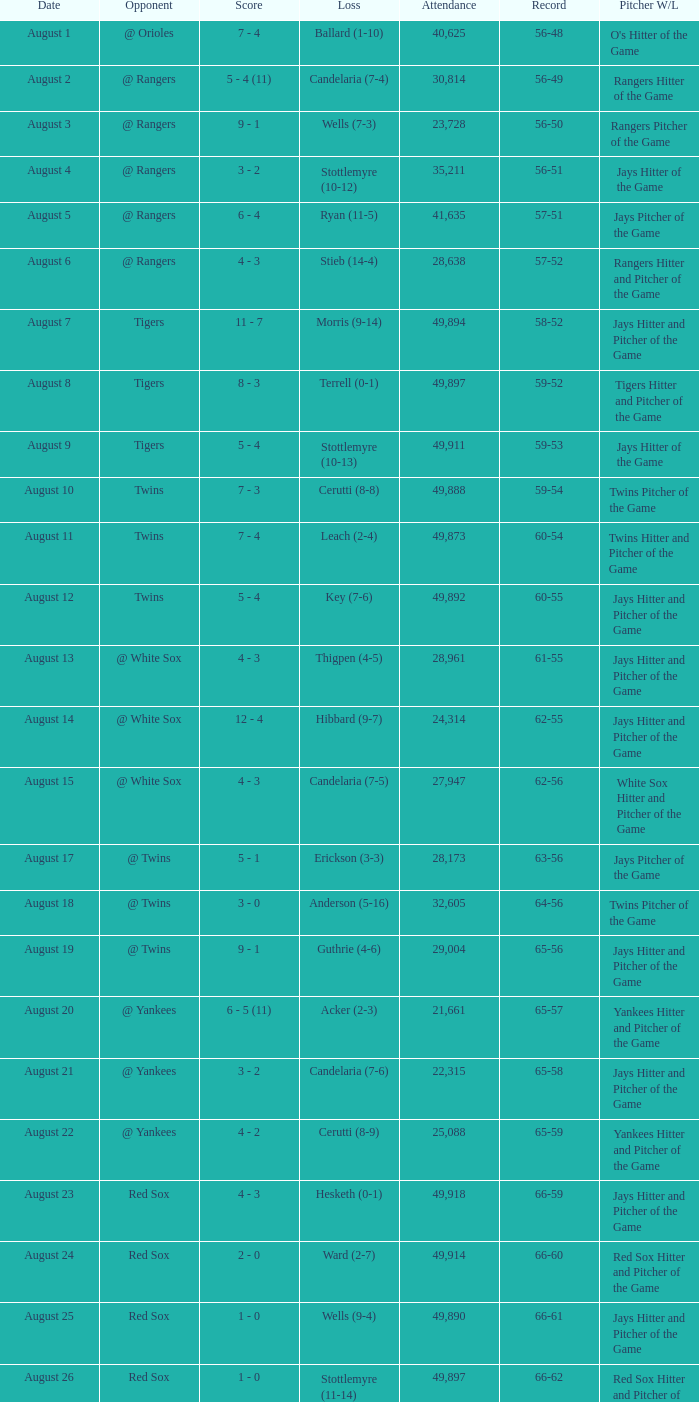Help me parse the entirety of this table. {'header': ['Date', 'Opponent', 'Score', 'Loss', 'Attendance', 'Record', 'Pitcher W/L'], 'rows': [['August 1', '@ Orioles', '7 - 4', 'Ballard (1-10)', '40,625', '56-48', "O's Hitter of the Game"], ['August 2', '@ Rangers', '5 - 4 (11)', 'Candelaria (7-4)', '30,814', '56-49', 'Rangers Hitter of the Game'], ['August 3', '@ Rangers', '9 - 1', 'Wells (7-3)', '23,728', '56-50', 'Rangers Pitcher of the Game'], ['August 4', '@ Rangers', '3 - 2', 'Stottlemyre (10-12)', '35,211', '56-51', 'Jays Hitter of the Game'], ['August 5', '@ Rangers', '6 - 4', 'Ryan (11-5)', '41,635', '57-51', 'Jays Pitcher of the Game'], ['August 6', '@ Rangers', '4 - 3', 'Stieb (14-4)', '28,638', '57-52', 'Rangers Hitter and Pitcher of the Game'], ['August 7', 'Tigers', '11 - 7', 'Morris (9-14)', '49,894', '58-52', 'Jays Hitter and Pitcher of the Game'], ['August 8', 'Tigers', '8 - 3', 'Terrell (0-1)', '49,897', '59-52', 'Tigers Hitter and Pitcher of the Game'], ['August 9', 'Tigers', '5 - 4', 'Stottlemyre (10-13)', '49,911', '59-53', 'Jays Hitter of the Game'], ['August 10', 'Twins', '7 - 3', 'Cerutti (8-8)', '49,888', '59-54', 'Twins Pitcher of the Game'], ['August 11', 'Twins', '7 - 4', 'Leach (2-4)', '49,873', '60-54', 'Twins Hitter and Pitcher of the Game'], ['August 12', 'Twins', '5 - 4', 'Key (7-6)', '49,892', '60-55', 'Jays Hitter and Pitcher of the Game'], ['August 13', '@ White Sox', '4 - 3', 'Thigpen (4-5)', '28,961', '61-55', 'Jays Hitter and Pitcher of the Game'], ['August 14', '@ White Sox', '12 - 4', 'Hibbard (9-7)', '24,314', '62-55', 'Jays Hitter and Pitcher of the Game'], ['August 15', '@ White Sox', '4 - 3', 'Candelaria (7-5)', '27,947', '62-56', 'White Sox Hitter and Pitcher of the Game'], ['August 17', '@ Twins', '5 - 1', 'Erickson (3-3)', '28,173', '63-56', 'Jays Pitcher of the Game'], ['August 18', '@ Twins', '3 - 0', 'Anderson (5-16)', '32,605', '64-56', 'Twins Pitcher of the Game'], ['August 19', '@ Twins', '9 - 1', 'Guthrie (4-6)', '29,004', '65-56', 'Jays Hitter and Pitcher of the Game'], ['August 20', '@ Yankees', '6 - 5 (11)', 'Acker (2-3)', '21,661', '65-57', 'Yankees Hitter and Pitcher of the Game'], ['August 21', '@ Yankees', '3 - 2', 'Candelaria (7-6)', '22,315', '65-58', 'Jays Hitter and Pitcher of the Game'], ['August 22', '@ Yankees', '4 - 2', 'Cerutti (8-9)', '25,088', '65-59', 'Yankees Hitter and Pitcher of the Game'], ['August 23', 'Red Sox', '4 - 3', 'Hesketh (0-1)', '49,918', '66-59', 'Jays Hitter and Pitcher of the Game'], ['August 24', 'Red Sox', '2 - 0', 'Ward (2-7)', '49,914', '66-60', 'Red Sox Hitter and Pitcher of the Game'], ['August 25', 'Red Sox', '1 - 0', 'Wells (9-4)', '49,890', '66-61', 'Jays Hitter and Pitcher of the Game'], ['August 26', 'Red Sox', '1 - 0', 'Stottlemyre (11-14)', '49,897', '66-62', 'Red Sox Hitter and Pitcher of the Game'], ['August 27', 'Brewers', '4 - 2', 'Acker (2-4)', '49,892', '66-63', 'Jays Hitter and Pitcher of the Game'], ['August 28', 'Brewers', '6 - 2', 'Stieb (16-5)', '49,871', '66-64', 'Brewers Hitter and Pitcher of the Game'], ['August 29', 'Brewers', '7 - 3', 'Knudson (10-7)', '49,909', '67-64', 'Brewers Hitter and Pitcher of the Game'], ['August 31', '@ Indians', '12 - 8', 'Swindell (10-8)', '12,508', '68-64', 'Indians Hitter and Pitcher of the Game']]} What was the record of the game that had a loss of Stottlemyre (10-12)? 56-51. 